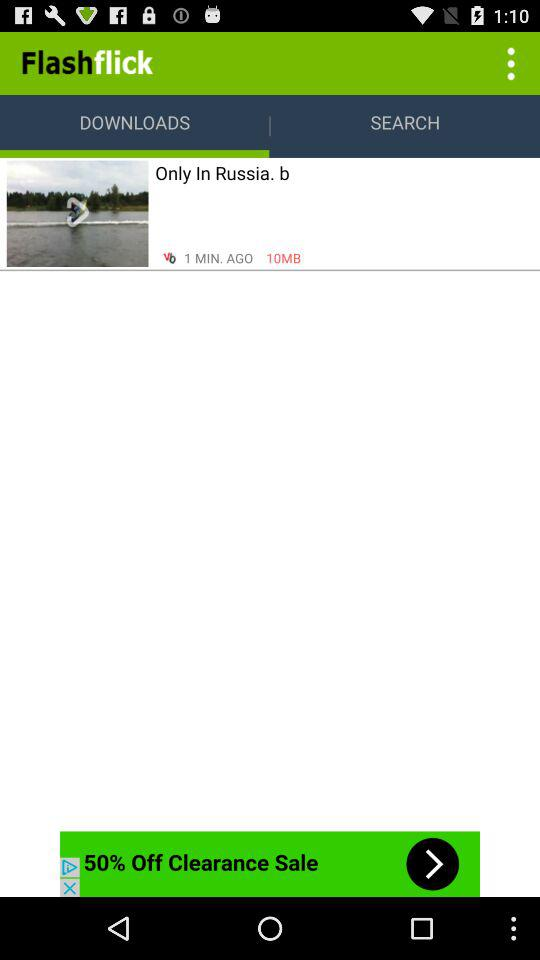What is the name of the developer? The name of the developer is "Flashflick". 